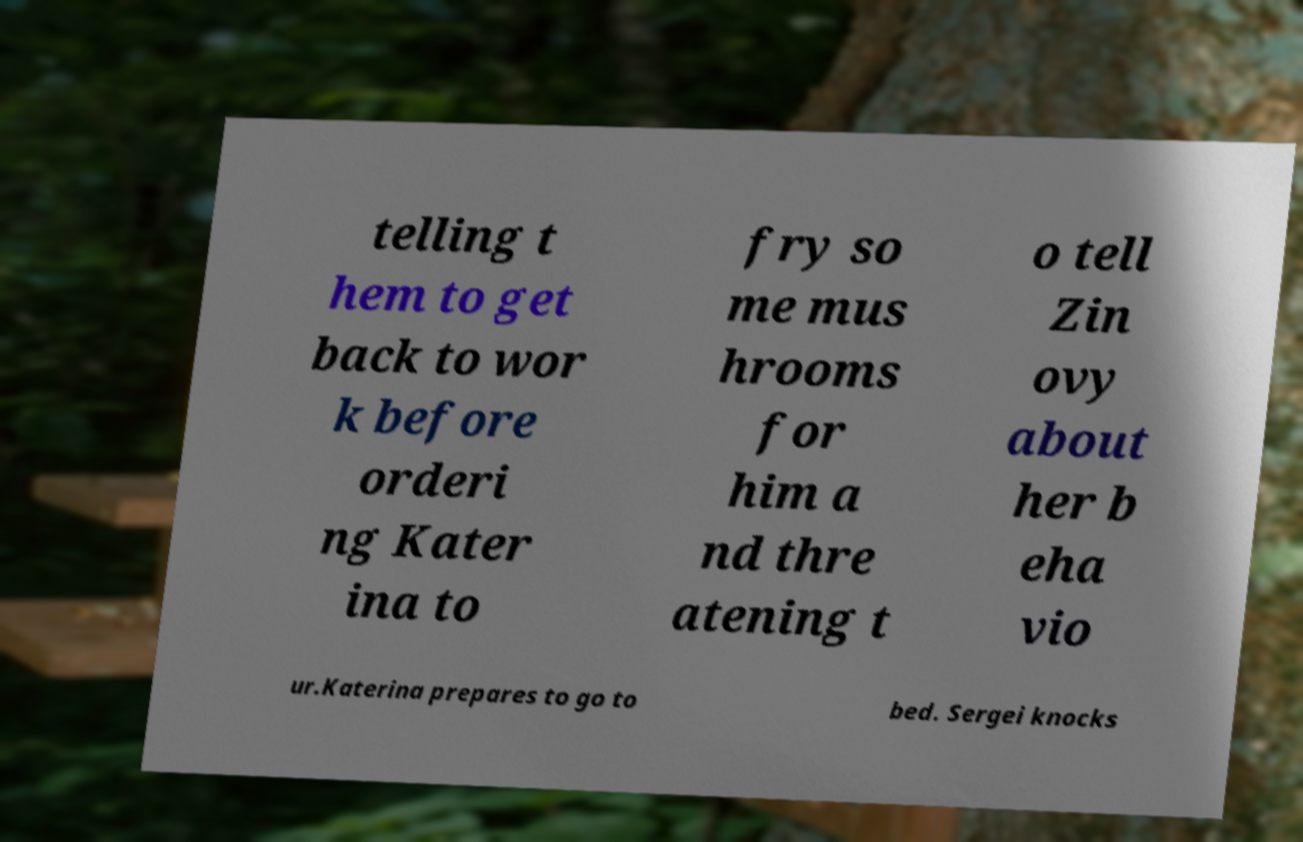What messages or text are displayed in this image? I need them in a readable, typed format. telling t hem to get back to wor k before orderi ng Kater ina to fry so me mus hrooms for him a nd thre atening t o tell Zin ovy about her b eha vio ur.Katerina prepares to go to bed. Sergei knocks 